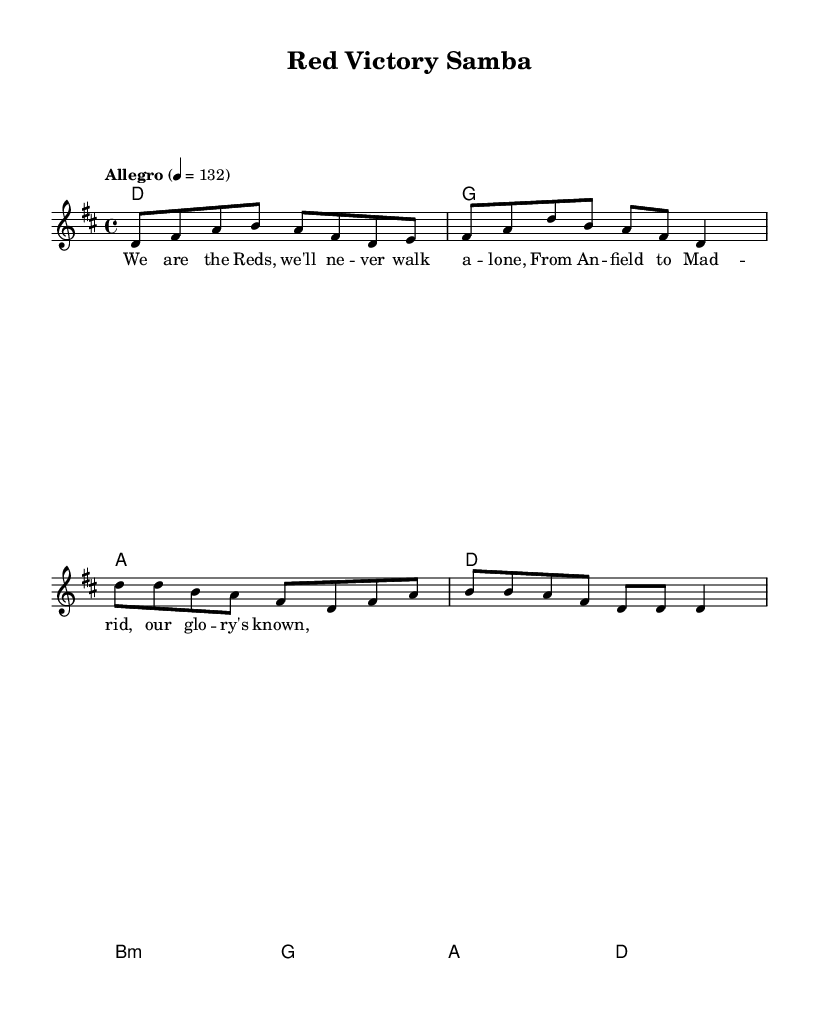What is the key signature of this music? The key signature relates to the key of D major, which has two sharps: F# and C#. This can be identified at the beginning of the staff where the sharps are placed.
Answer: D major What is the time signature of this music? The time signature indicates the number of beats in each measure and is listed at the beginning of the music. Here, the time signature is 4/4, suggesting there are four beats per measure.
Answer: 4/4 What is the tempo marking and its value? The tempo marking shows how fast the piece should be played. In this sheet music, it states "Allegro" and is set at a tempo of 132 beats per minute. The number indicates the speed at which the quarter note is played.
Answer: Allegro 4 = 132 What is the first note of the melody? The melody section starts with the note D, which is the first note written in the relative notation at the beginning of the melody line.
Answer: D How many measures are in the chorus? The chorus section is identified in the music and consists of a total of four measures. By counting the measures present in the chorus part, we find that there are four.
Answer: 4 What kind of chord is played in the fifth measure? In the fifth measure, there is a B minor chord indicated by the notation "b1:m". It’s specifically noted with a lowercase "m" which designates it as a minor chord.
Answer: B minor What beats are emphasized in the samba rhythm of this piece? Samba rhythms typically emphasize the second and fourth beats within the 4/4 time signature. Additionally, they are often characterized by syncopation. Observing how the melody and harmony interact can help deduce the emphasis.
Answer: 2 and 4 